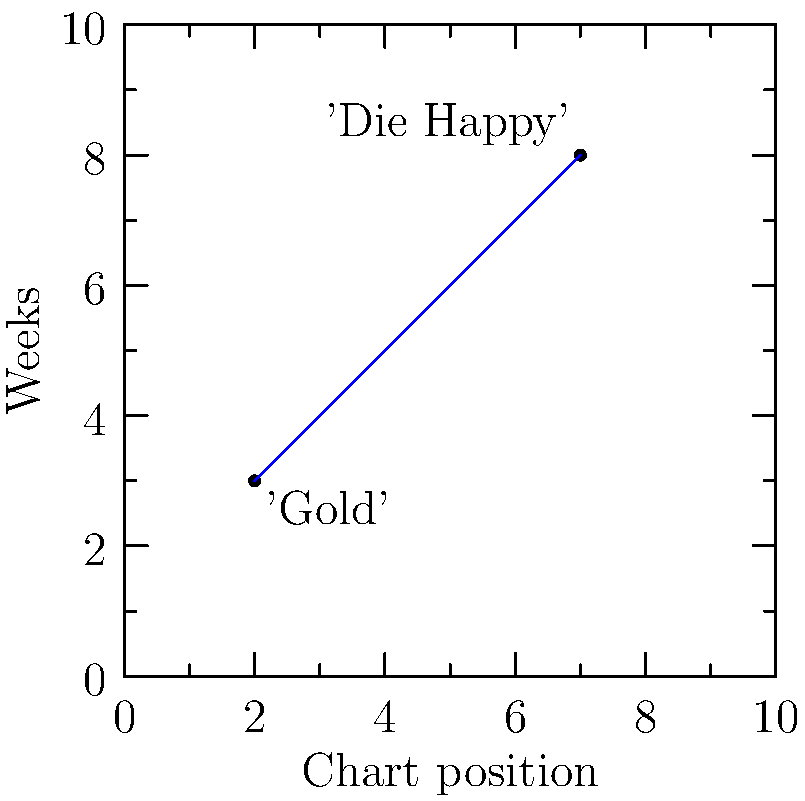The Starlings' hit single 'Gold' peaked at position 2 on the Belgian charts and stayed there for 3 weeks. Their follow-up single 'Die Happy' reached position 7 and remained for 8 weeks. Using the chart position as the x-axis and the number of weeks as the y-axis, determine the equation of the line passing through these two points in slope-intercept form $(y = mx + b)$. What does the slope of this line represent in the context of The Starlings' chart performance? Let's approach this step-by-step:

1) We have two points: (2,3) for 'Gold' and (7,8) for 'Die Happy'.

2) To find the slope (m), we use the formula:
   $m = \frac{y_2 - y_1}{x_2 - x_1} = \frac{8 - 3}{7 - 2} = \frac{5}{5} = 1$

3) Now we have $y = x + b$. We can use either point to find $b$. Let's use (2,3):
   $3 = 1(2) + b$
   $3 = 2 + b$
   $b = 1$

4) Therefore, the equation of the line is $y = x + 1$

5) Interpreting the slope: A slope of 1 means that for every 1 position lower on the chart (moving right on the x-axis), the song stays 1 week longer on the chart. This suggests that lower-charting songs by The Starlings tend to have more longevity on the charts.
Answer: $y = x + 1$; slope represents the relationship between chart position and longevity. 